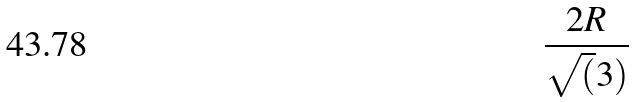Convert formula to latex. <formula><loc_0><loc_0><loc_500><loc_500>\frac { 2 R } { \sqrt { ( } 3 ) }</formula> 